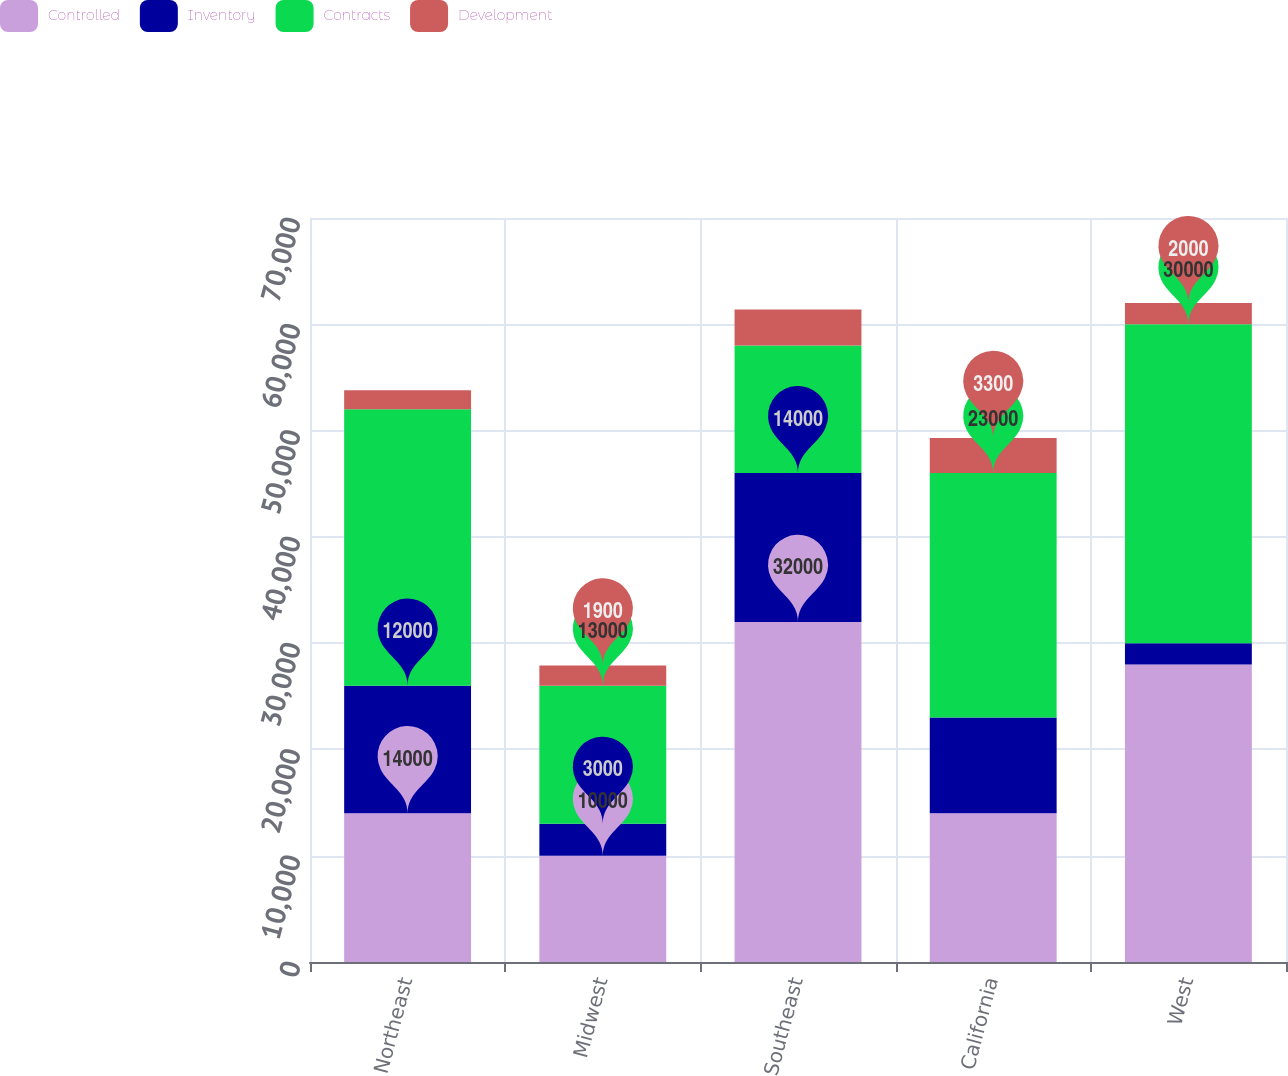Convert chart to OTSL. <chart><loc_0><loc_0><loc_500><loc_500><stacked_bar_chart><ecel><fcel>Northeast<fcel>Midwest<fcel>Southeast<fcel>California<fcel>West<nl><fcel>Controlled<fcel>14000<fcel>10000<fcel>32000<fcel>14000<fcel>28000<nl><fcel>Inventory<fcel>12000<fcel>3000<fcel>14000<fcel>9000<fcel>2000<nl><fcel>Contracts<fcel>26000<fcel>13000<fcel>12000<fcel>23000<fcel>30000<nl><fcel>Development<fcel>1800<fcel>1900<fcel>3400<fcel>3300<fcel>2000<nl></chart> 